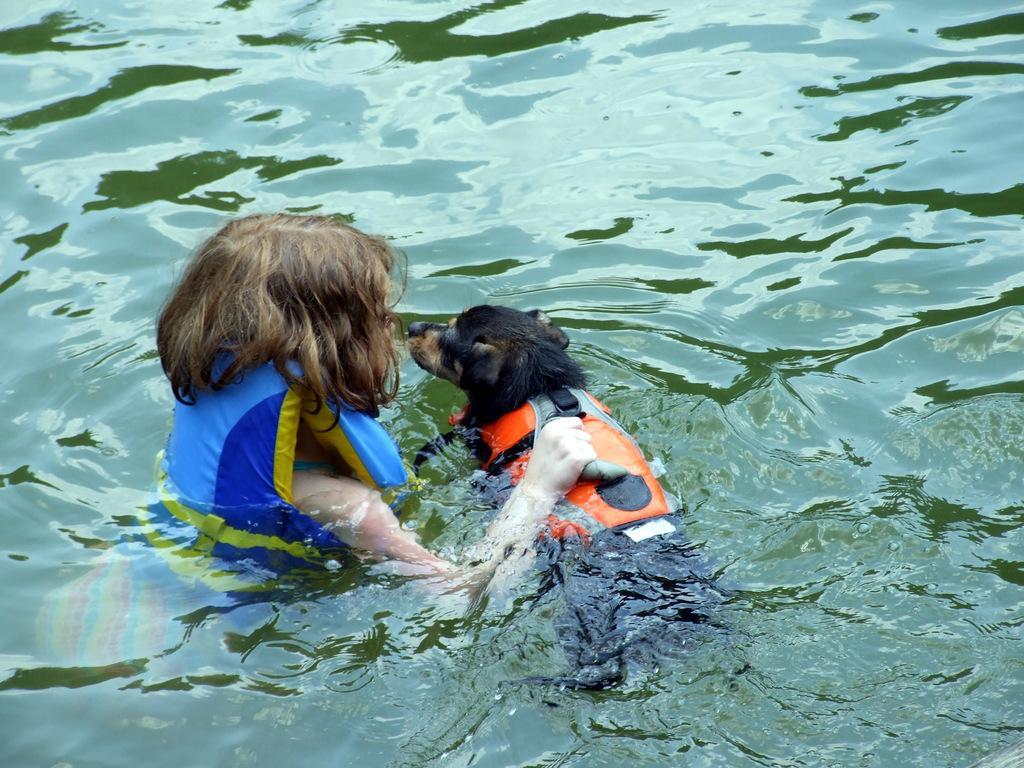Describe this image in one or two sentences. In this image I can see a person and the dog and they are in the water. 